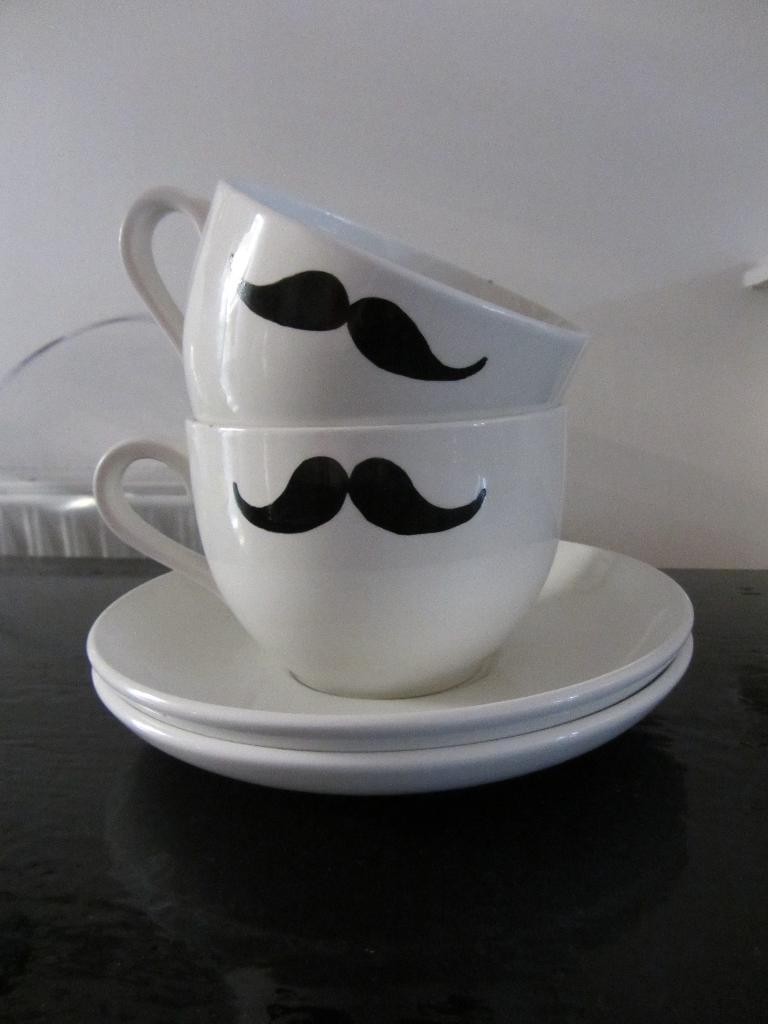What objects are on the table in the image? There are cups and saucers on the table in the image. Where are the cups and saucers located? The cups and saucers are on a table. What can be seen in the background of the image? There is a wall in the background of the image. How many stars can be seen on the table in the image? There are no stars present on the table in the image. What type of crush is the person in the image experiencing? There is no person in the image, and therefore no indication of any emotions or experiences. 